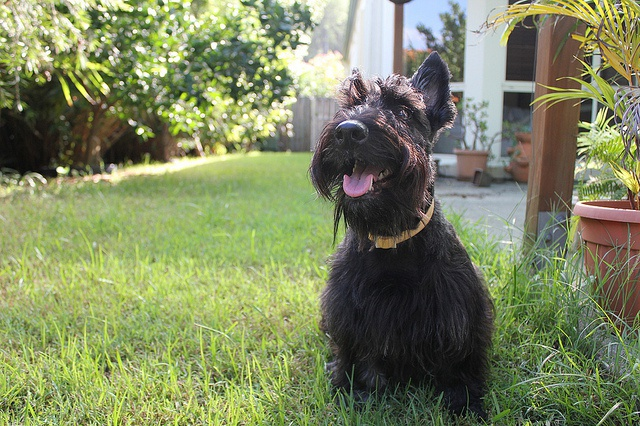Describe the objects in this image and their specific colors. I can see dog in beige, black, gray, and darkgray tones, potted plant in beige, gray, olive, and maroon tones, potted plant in beige, gray, darkgray, and lightblue tones, and potted plant in beige, gray, and maroon tones in this image. 